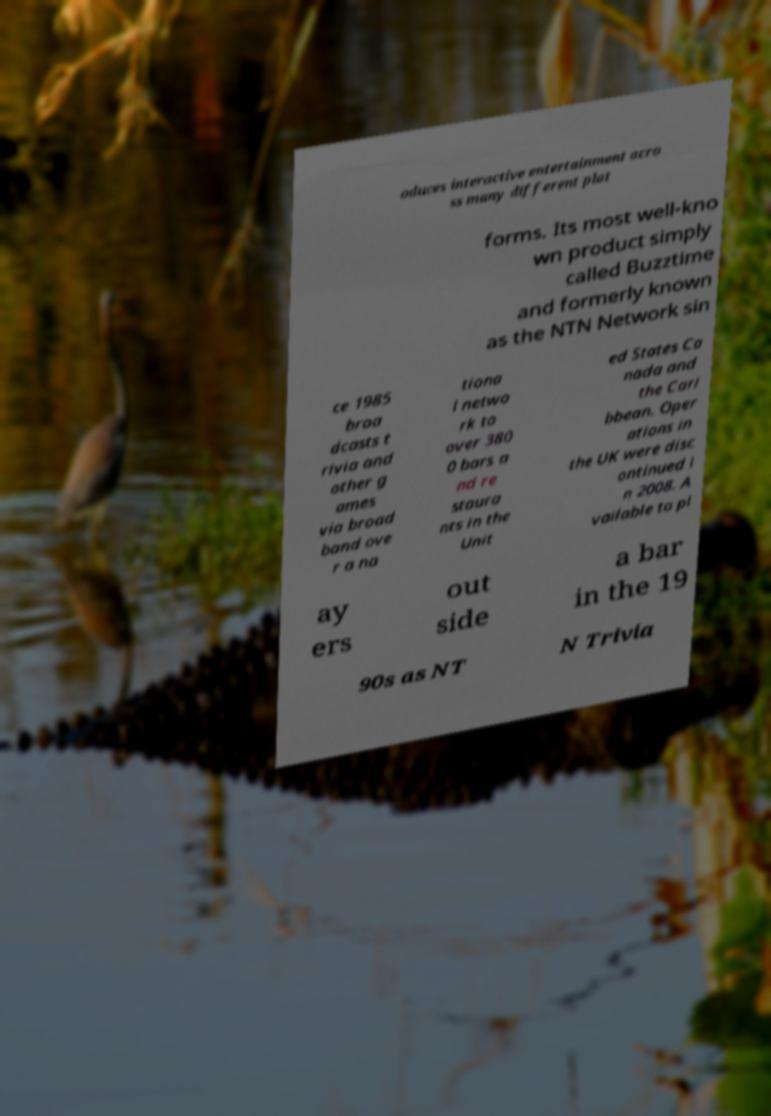What messages or text are displayed in this image? I need them in a readable, typed format. oduces interactive entertainment acro ss many different plat forms. Its most well-kno wn product simply called Buzztime and formerly known as the NTN Network sin ce 1985 broa dcasts t rivia and other g ames via broad band ove r a na tiona l netwo rk to over 380 0 bars a nd re staura nts in the Unit ed States Ca nada and the Cari bbean. Oper ations in the UK were disc ontinued i n 2008. A vailable to pl ay ers out side a bar in the 19 90s as NT N Trivia 